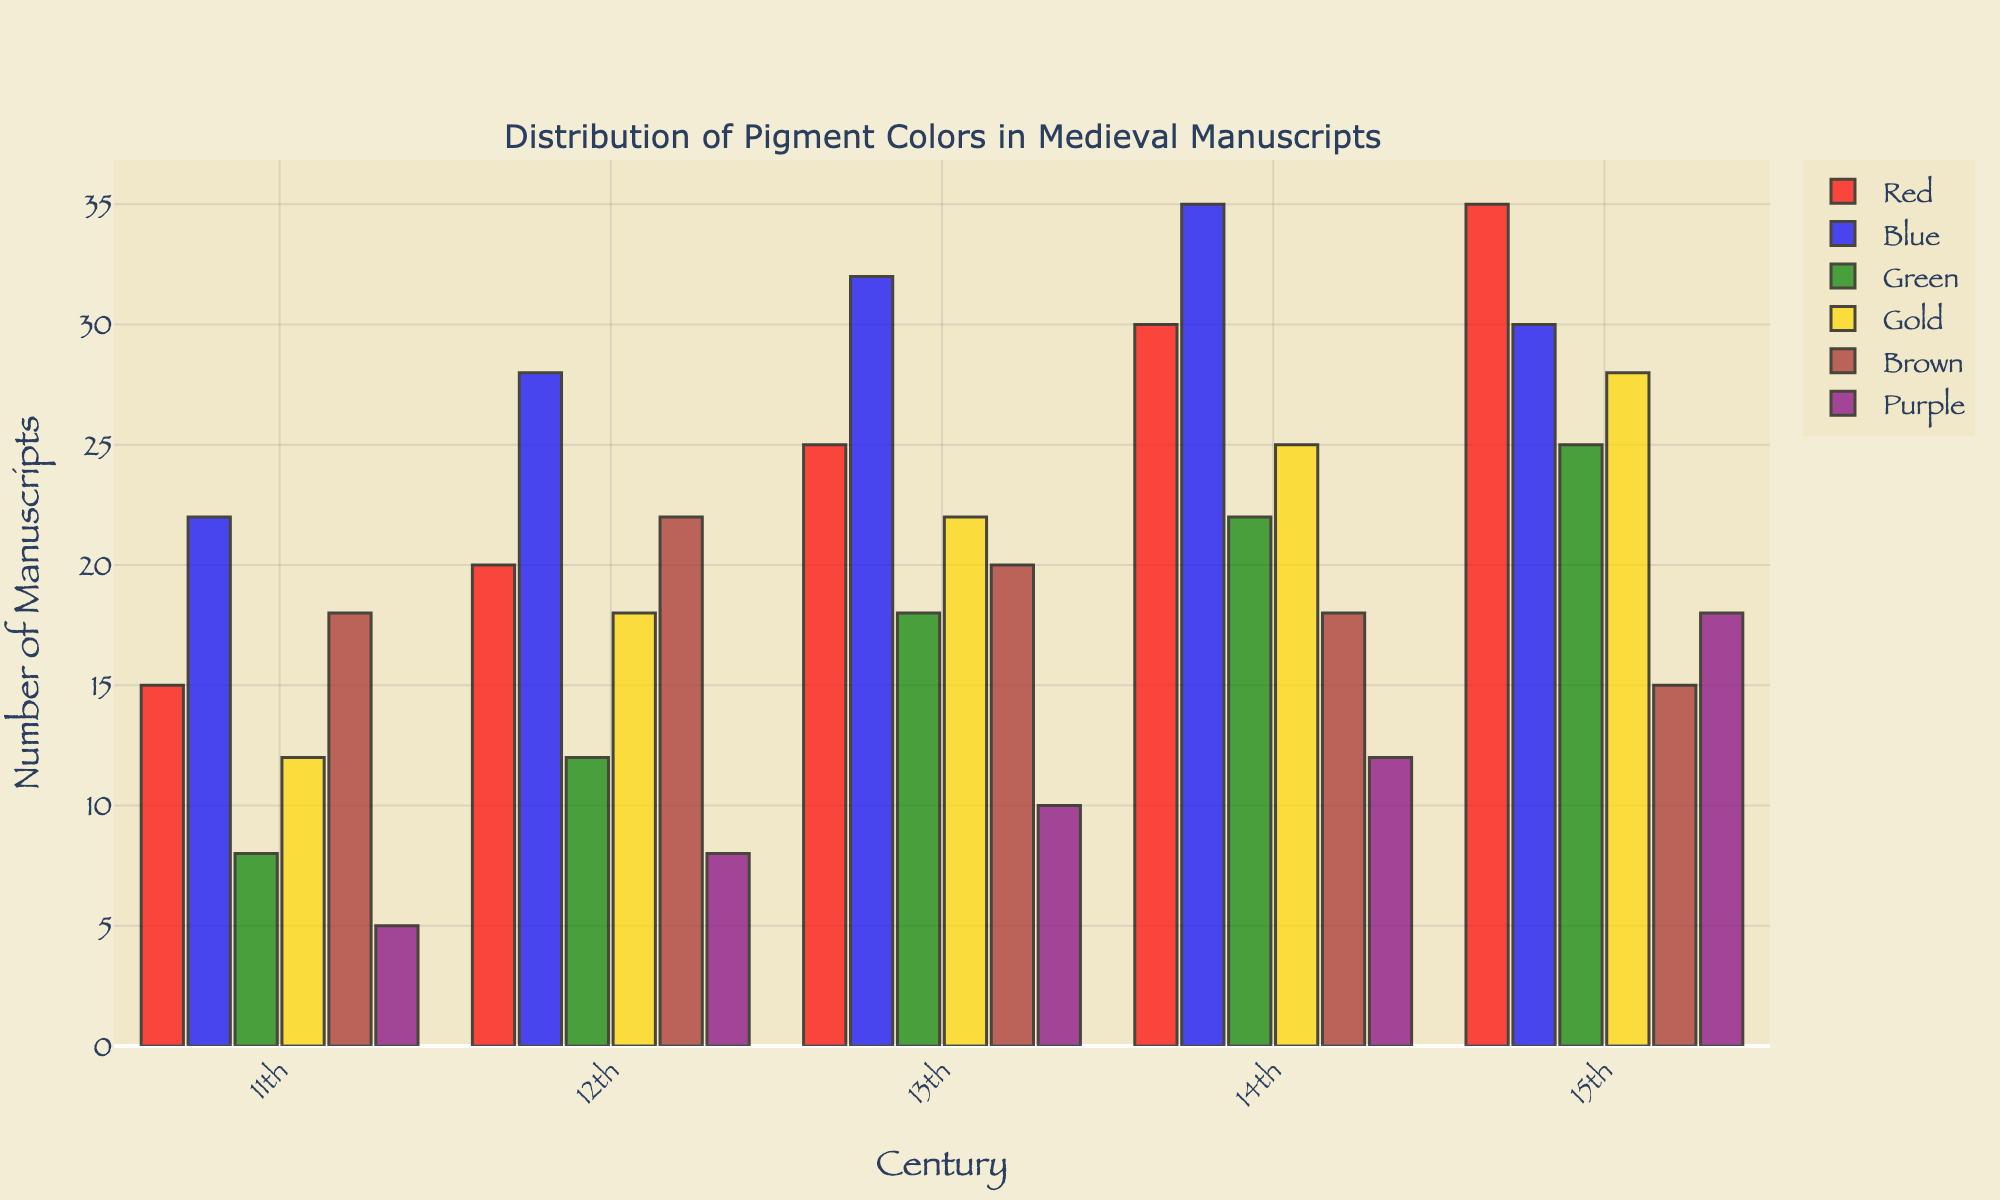Which century used the highest number of red pigment colors? Observe the bar graph, look for the tallest red bar, which represents the highest value. The tallest red bar appears in the 15th century.
Answer: 15th century In which century did the number of gold pigments surpass 20 manuscripts? Review the gold bars and find the one which exceeds the 20-mark. The 15th-century gold bar surpasses 20 manuscripts, reaching 28.
Answer: 15th century How does the usage of blue pigments in the 12th century compare to the 14th century? Compare the height of the blue bars between the two centuries. The blue bar in the 12th century is lower than the blue bar in the 14th century.
Answer: Less in the 12th century Which color saw the greatest increase in usage from the 11th to the 15th century? Calculate the difference for each color between the 15th and 11th centuries. Red increased by 20 (35-15), blue by 8 (30-22), green by 17 (25-8), gold by 16 (28-12), brown by -3 (15-18), and purple by 13 (18-5). The color with the greatest increase is red.
Answer: Red What is the total number of manuscripts using green pigments in the 12th and 13th centuries combined? Add the number of green pigments in the 12th century (12) and in the 13th century (18). 12 + 18 = 30.
Answer: 30 Which pigment was used least often in the 13th century? Identify the shortest bar for the 13th century. The shortest bar represents purple, with a value of 10.
Answer: Purple Calculate the average number of manuscripts using brown pigment over all centuries. Sum the values of brown pigments (18 + 22 + 20 + 18 + 15) and divide by the number of centuries (5). (18 + 22 + 20 + 18 + 15) / 5 = 93 / 5 = 18.6.
Answer: 18.6 Is the number of purple pigments in the 14th century greater than the number of green pigments in the 11th century? Compare the height of the purple bar in the 14th century (12) with the green bar in the 11th century (8). 12 is greater than 8.
Answer: Yes What is the combined number of manuscripts using red and blue pigments in the 13th century? Sum the numbers for red (25) and blue (32) pigments in the 13th century. 25 + 32 = 57.
Answer: 57 